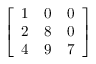Convert formula to latex. <formula><loc_0><loc_0><loc_500><loc_500>\left [ \begin{array} { l l l } { 1 } & { 0 } & { 0 } \\ { 2 } & { 8 } & { 0 } \\ { 4 } & { 9 } & { 7 } \end{array} \right ]</formula> 